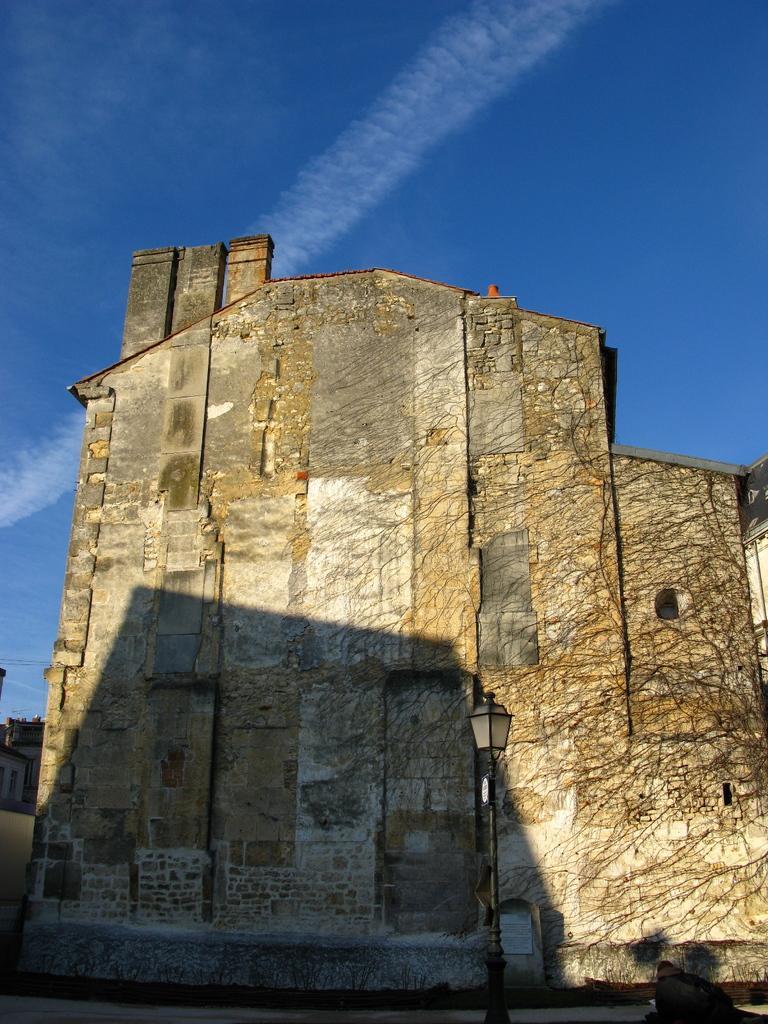How would you summarize this image in a sentence or two? In this image we can see a monument, pole, buildings, cables and sky with clouds. 